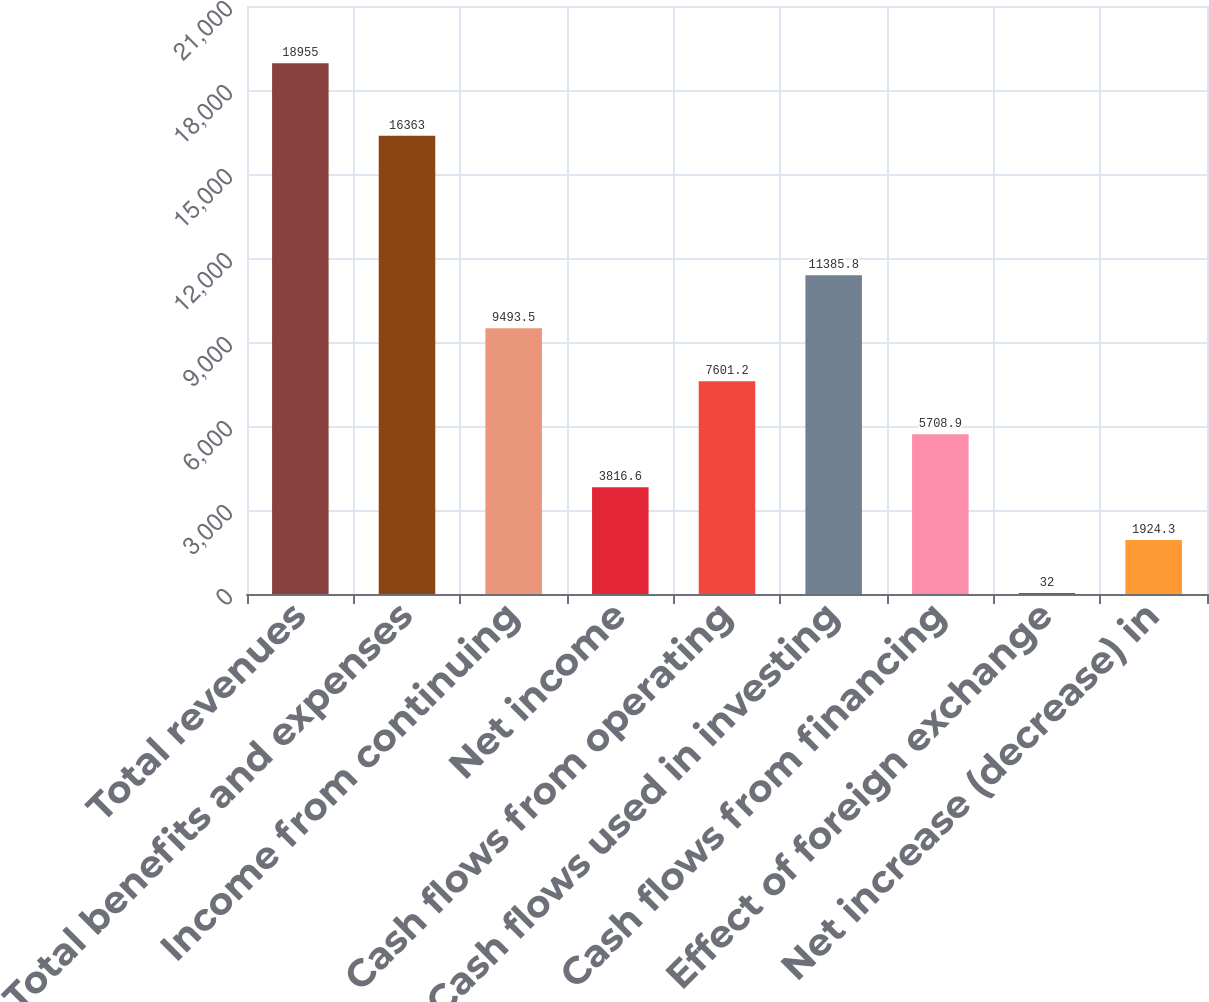<chart> <loc_0><loc_0><loc_500><loc_500><bar_chart><fcel>Total revenues<fcel>Total benefits and expenses<fcel>Income from continuing<fcel>Net income<fcel>Cash flows from operating<fcel>Cash flows used in investing<fcel>Cash flows from financing<fcel>Effect of foreign exchange<fcel>Net increase (decrease) in<nl><fcel>18955<fcel>16363<fcel>9493.5<fcel>3816.6<fcel>7601.2<fcel>11385.8<fcel>5708.9<fcel>32<fcel>1924.3<nl></chart> 